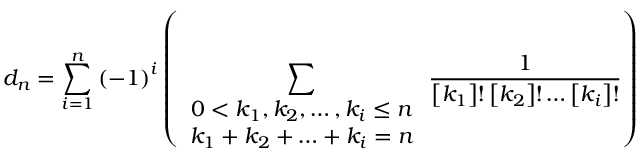<formula> <loc_0><loc_0><loc_500><loc_500>d _ { n } = \sum _ { i = 1 } ^ { n } { \left ( - 1 \right ) ^ { i } \left ( \sum _ { \begin{array} { c } { { 0 < k _ { 1 } , k _ { 2 } , \dots , k _ { i } \leq n } } \\ { { k _ { 1 } + k _ { 2 } + \dots + k _ { i } = n } } \end{array} } \frac { 1 } { \left [ k _ { 1 } \right ] ! \left [ k _ { 2 } \right ] ! \dots \left [ k _ { i } \right ] ! } \right ) }</formula> 